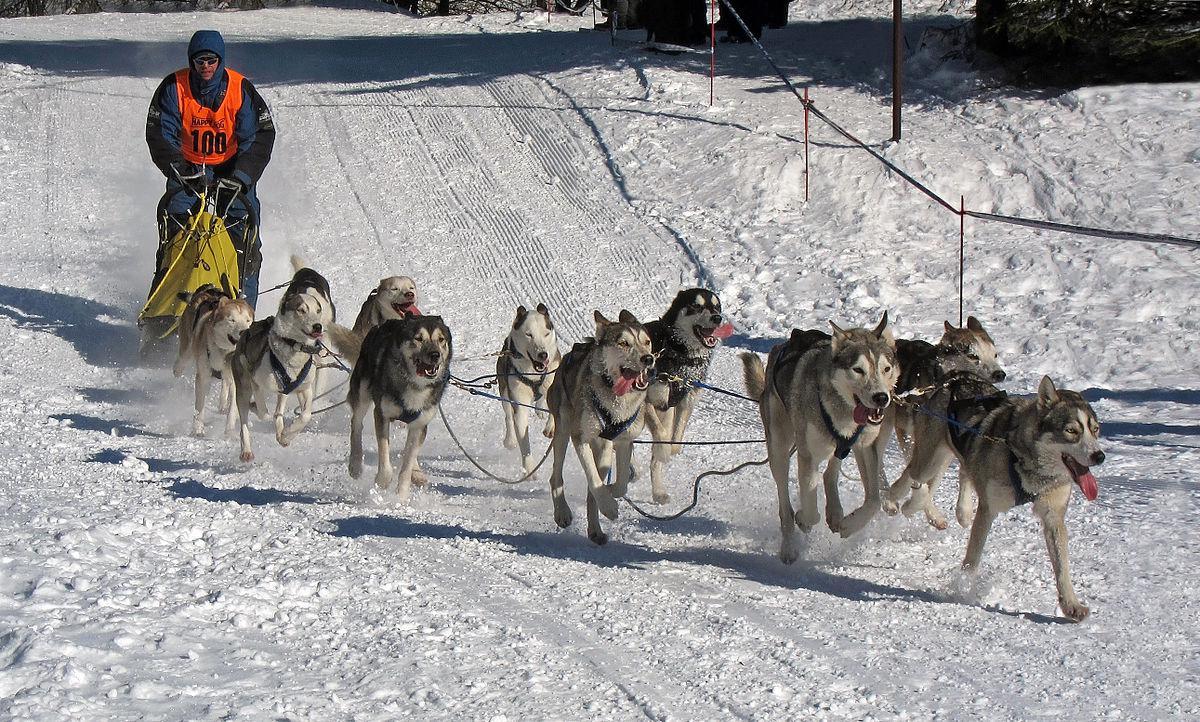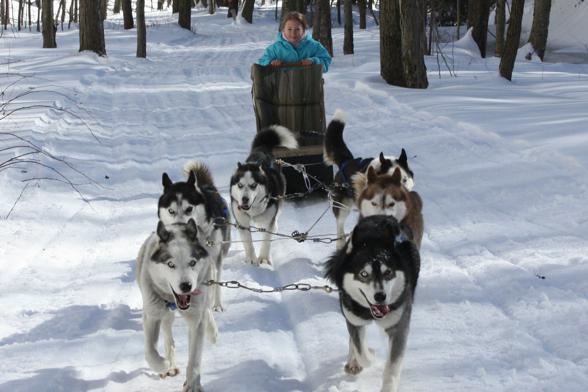The first image is the image on the left, the second image is the image on the right. Given the left and right images, does the statement "The dogs are pulling a sled with a person wearing orange in one of the images." hold true? Answer yes or no. Yes. The first image is the image on the left, the second image is the image on the right. Evaluate the accuracy of this statement regarding the images: "Right image shows a team of harnessed dogs heading leftward, with a line of trees in the background.". Is it true? Answer yes or no. No. 